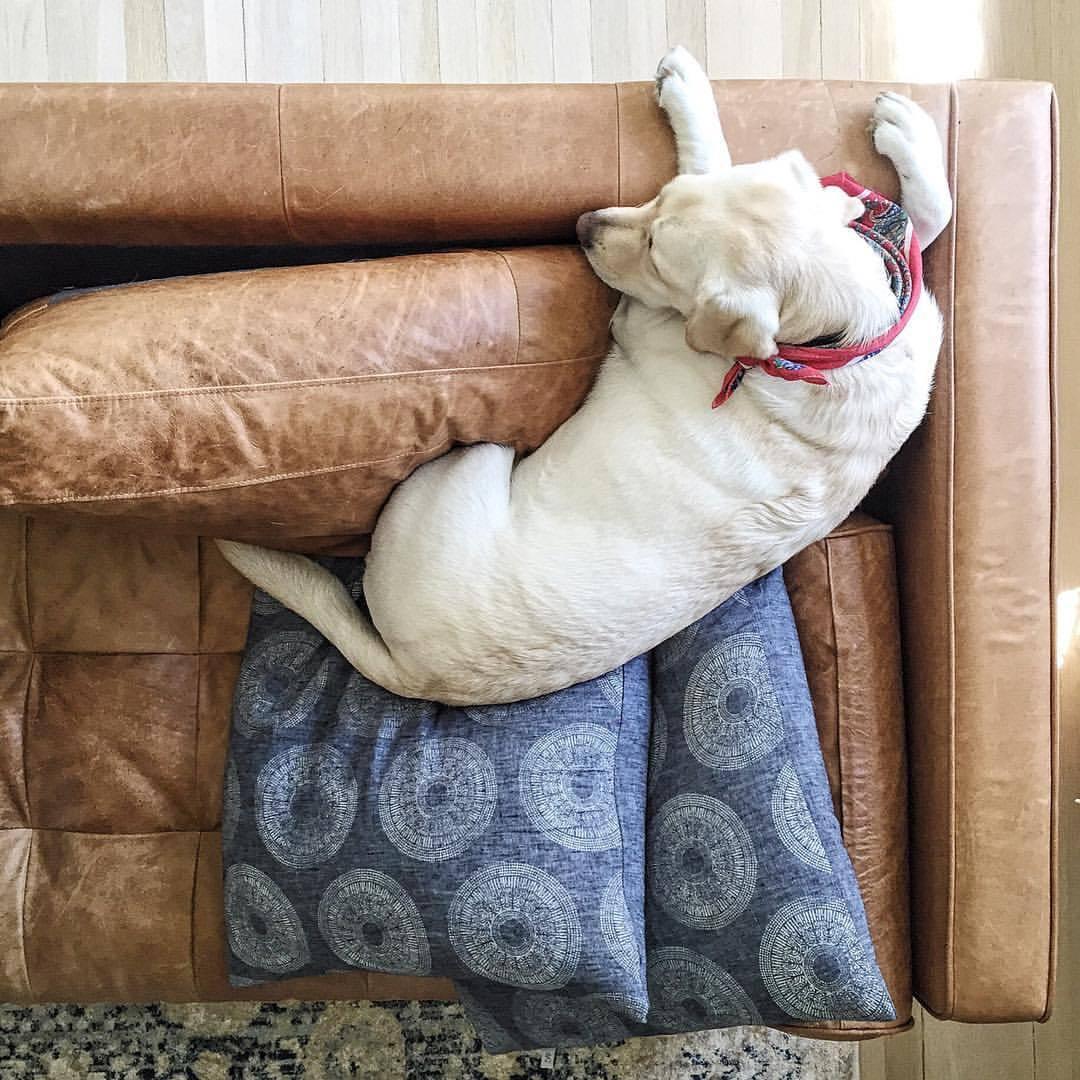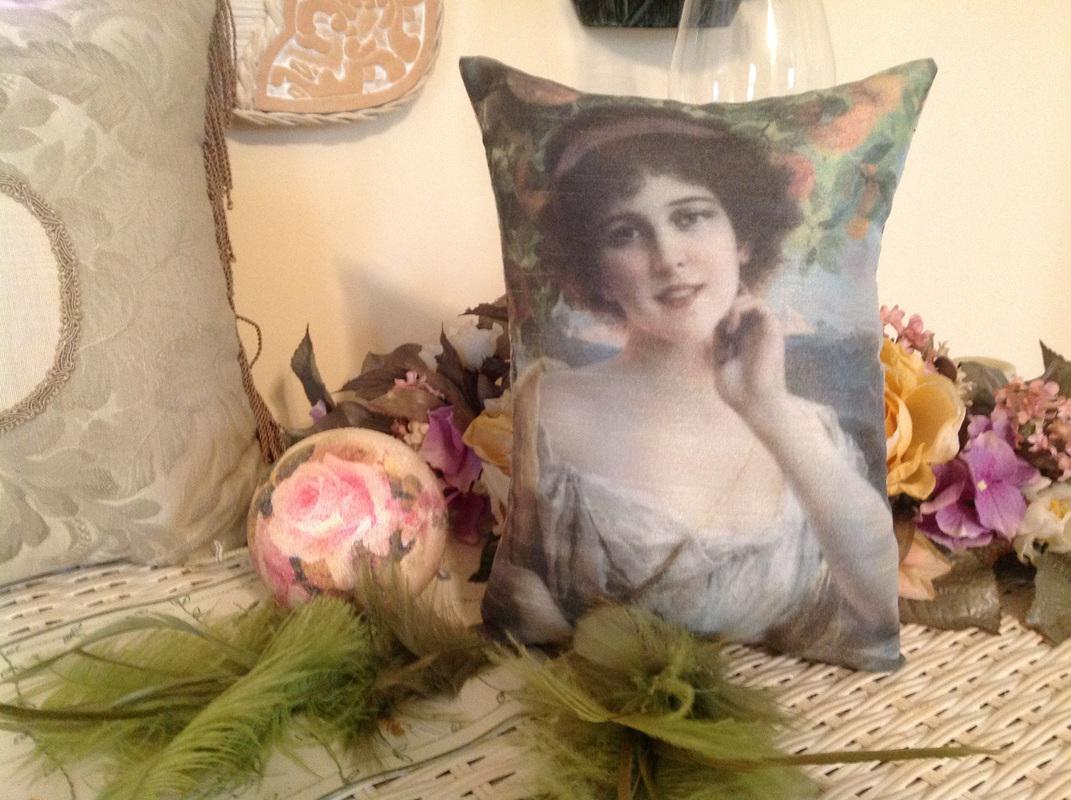The first image is the image on the left, the second image is the image on the right. Analyze the images presented: Is the assertion "In at least one image, a person is shown displaying fancy throw pillows." valid? Answer yes or no. No. 